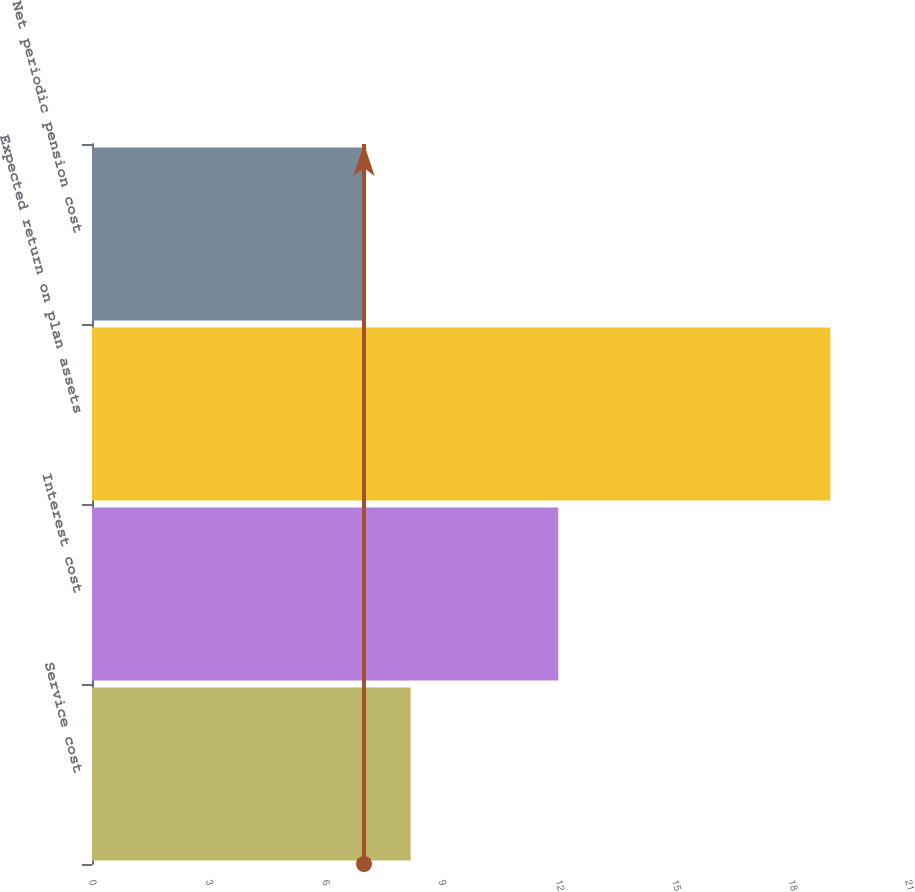Convert chart. <chart><loc_0><loc_0><loc_500><loc_500><bar_chart><fcel>Service cost<fcel>Interest cost<fcel>Expected return on plan assets<fcel>Net periodic pension cost<nl><fcel>8.2<fcel>12<fcel>19<fcel>7<nl></chart> 